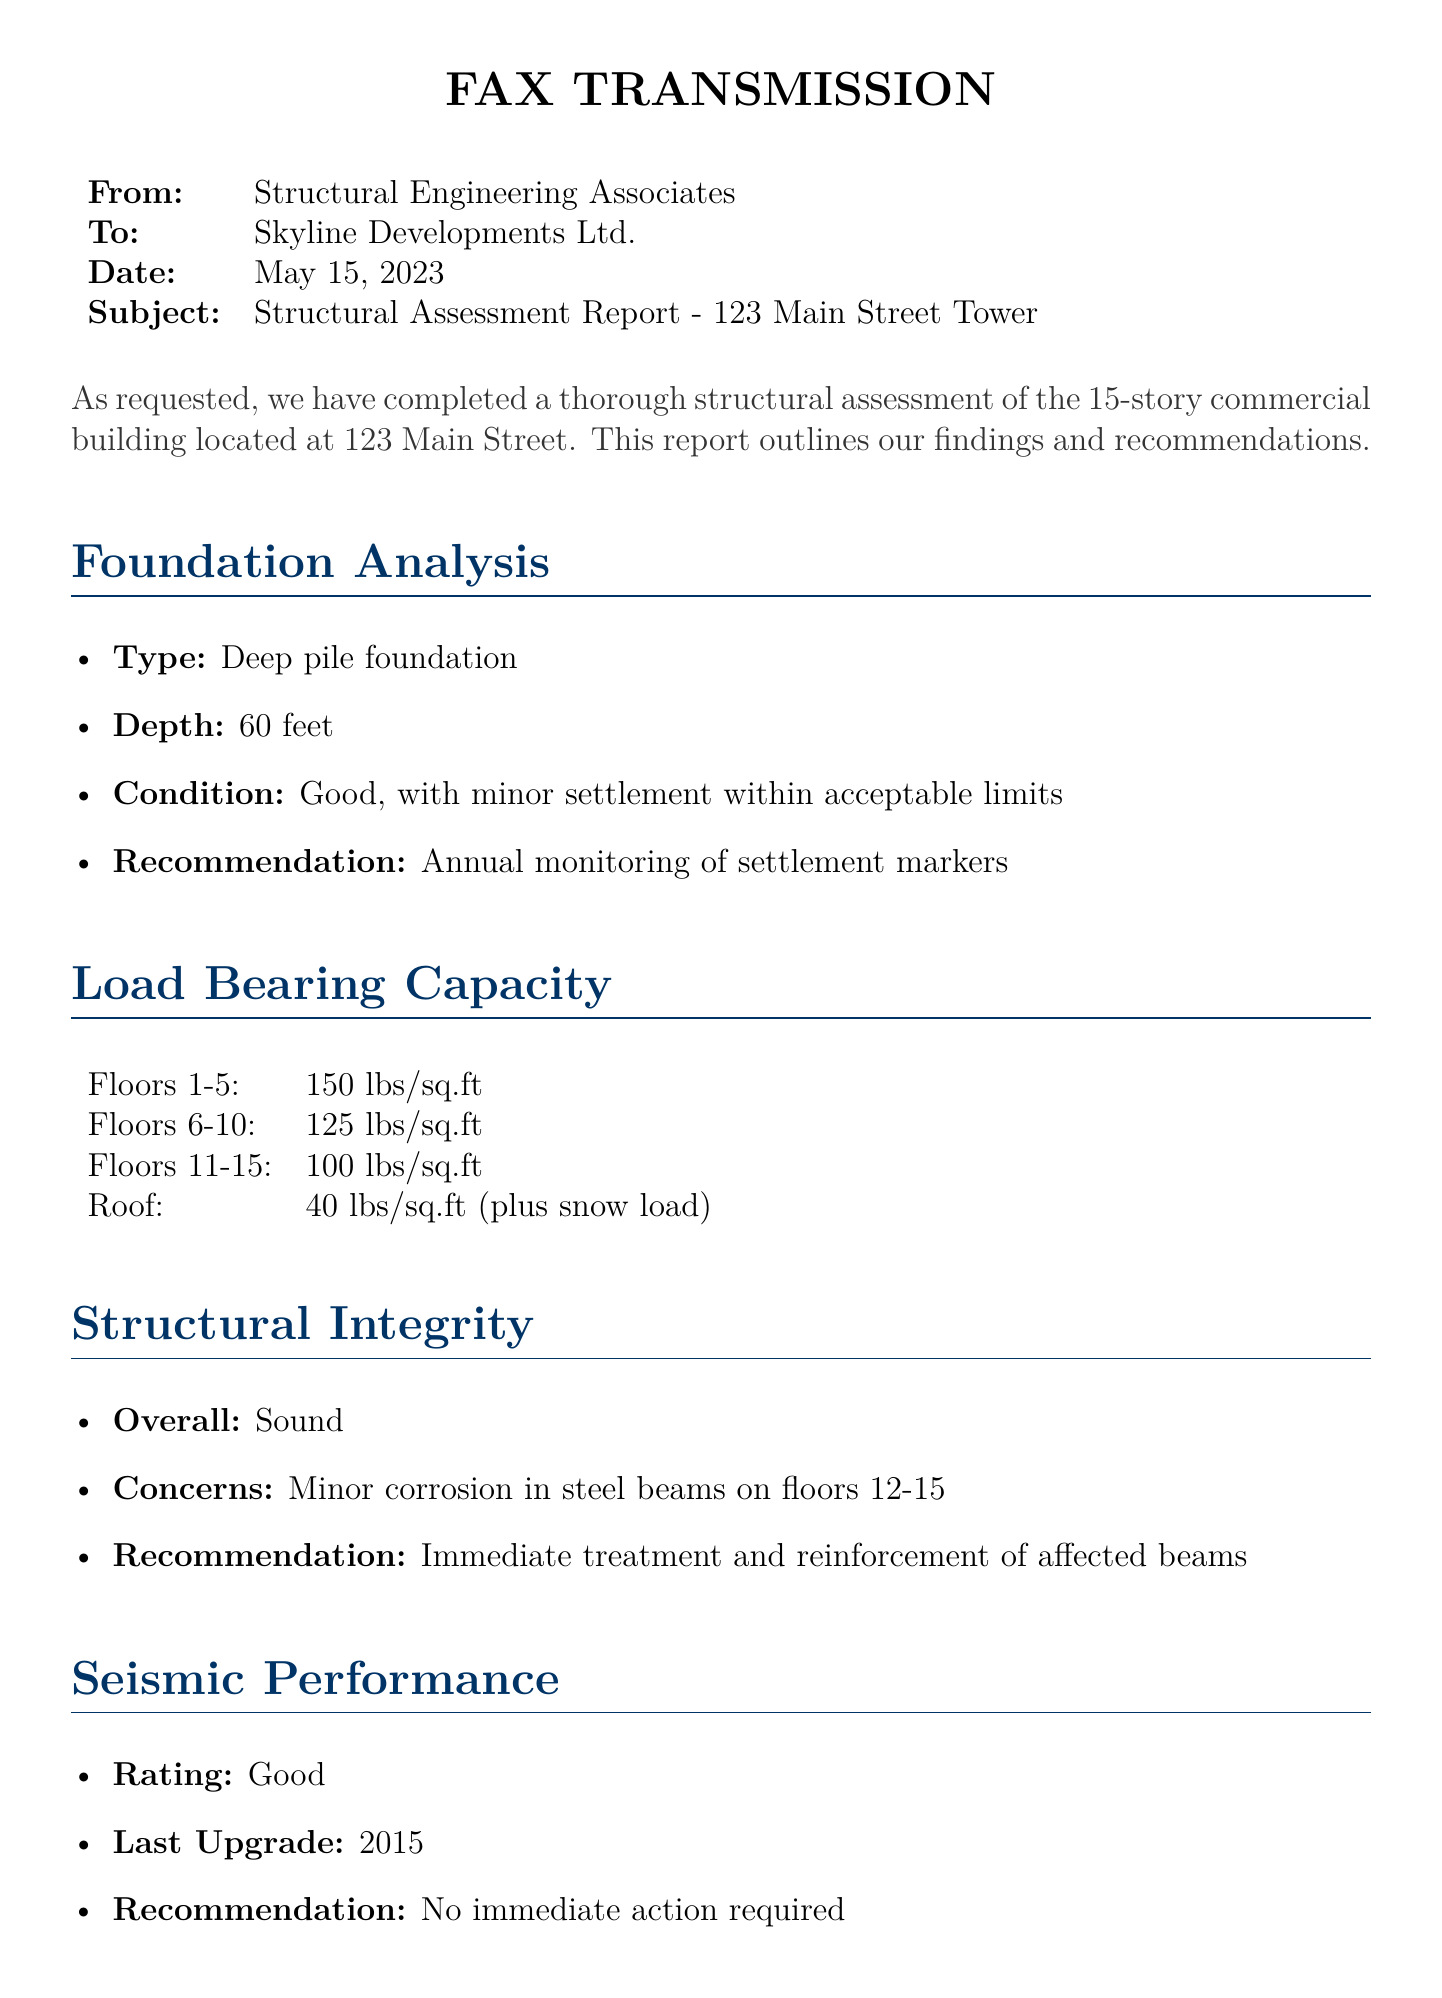what is the address of the building? The address of the building is stated in the subject line of the document.
Answer: 123 Main Street what type of foundation does the building have? The foundation type is detailed in the Foundation Analysis section.
Answer: Deep pile foundation what is the depth of the foundation? The foundation depth is specified in the Foundation Analysis section.
Answer: 60 feet what is the load-bearing capacity of the roof? The load-bearing capacity for the roof is mentioned in the Load Bearing Capacity section.
Answer: 40 lbs/sq.ft (plus snow load) what concerns were noted regarding structural integrity? The concerns about structural integrity are outlined in the Structural Integrity section.
Answer: Minor corrosion in steel beams on floors 12-15 what is the seismic performance rating of the building? The seismic performance rating is indicated in the Seismic Performance section.
Answer: Good who authored the structural assessment report? The author's name is found at the end of the document.
Answer: Emily Chen, P.E what is the recommended action for the corrosion found? The recommendation regarding corrosion is present in the Structural Integrity section.
Answer: Immediate treatment and reinforcement of affected beams what is the recommendation for the foundation monitoring? The recommendation regarding foundation monitoring is specified in the Foundation Analysis section.
Answer: Annual monitoring of settlement markers 